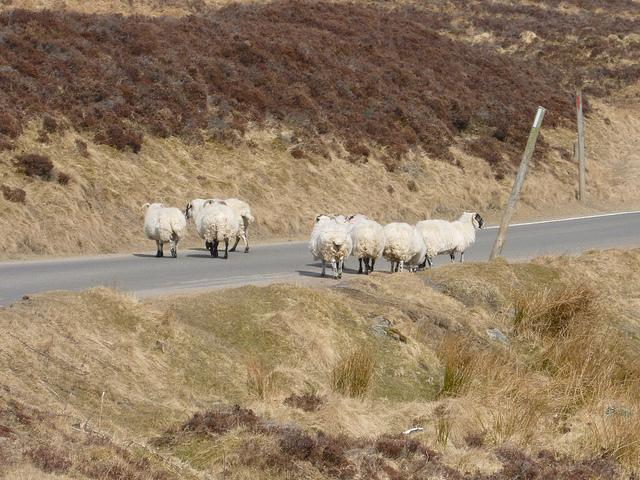What is the fur of the animal in this image commonly used for?

Choices:
A) carpets
B) cars
C) yard work
D) weapons carpets 